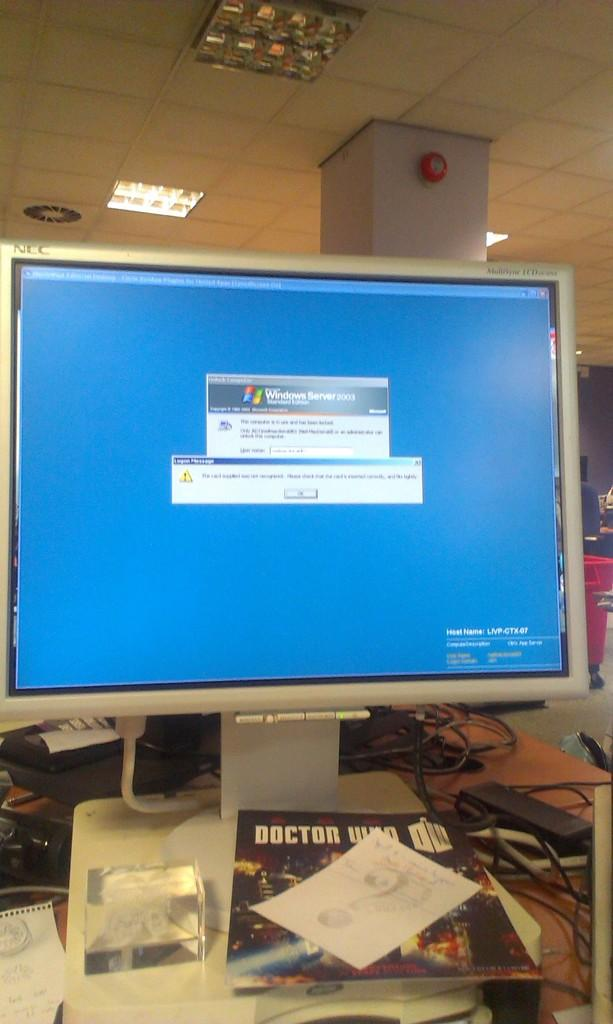<image>
Write a terse but informative summary of the picture. A computer monitor displays a blue screen and a Doctor Who comic book is underneath it on a desk. 